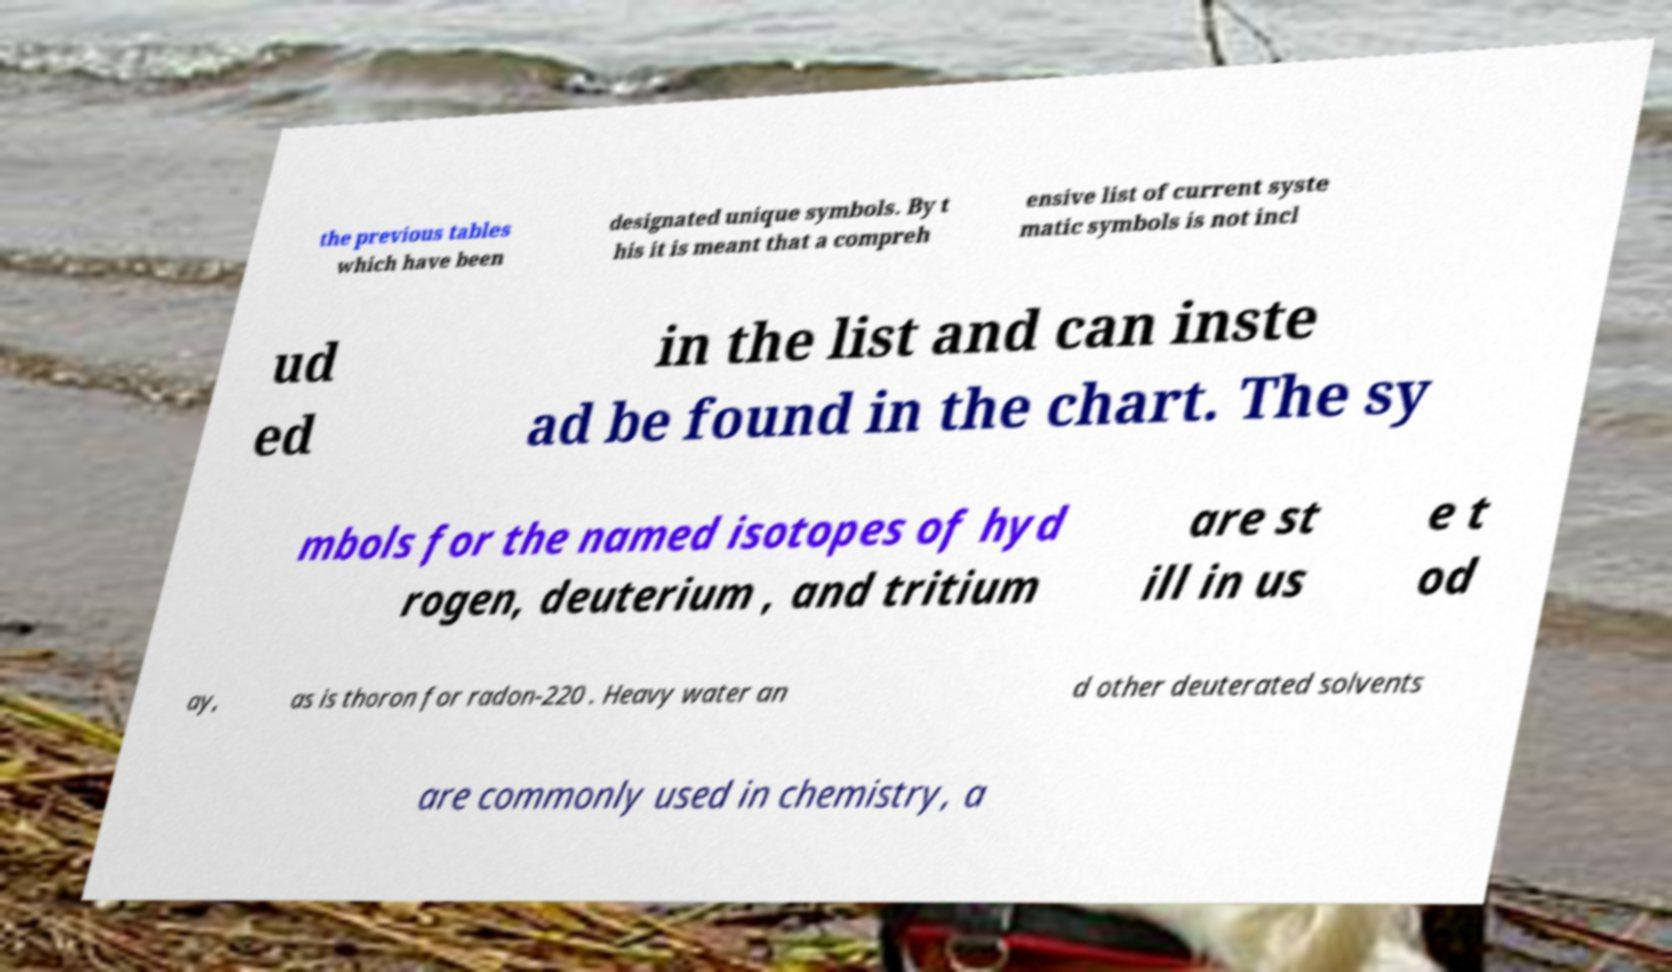What messages or text are displayed in this image? I need them in a readable, typed format. the previous tables which have been designated unique symbols. By t his it is meant that a compreh ensive list of current syste matic symbols is not incl ud ed in the list and can inste ad be found in the chart. The sy mbols for the named isotopes of hyd rogen, deuterium , and tritium are st ill in us e t od ay, as is thoron for radon-220 . Heavy water an d other deuterated solvents are commonly used in chemistry, a 